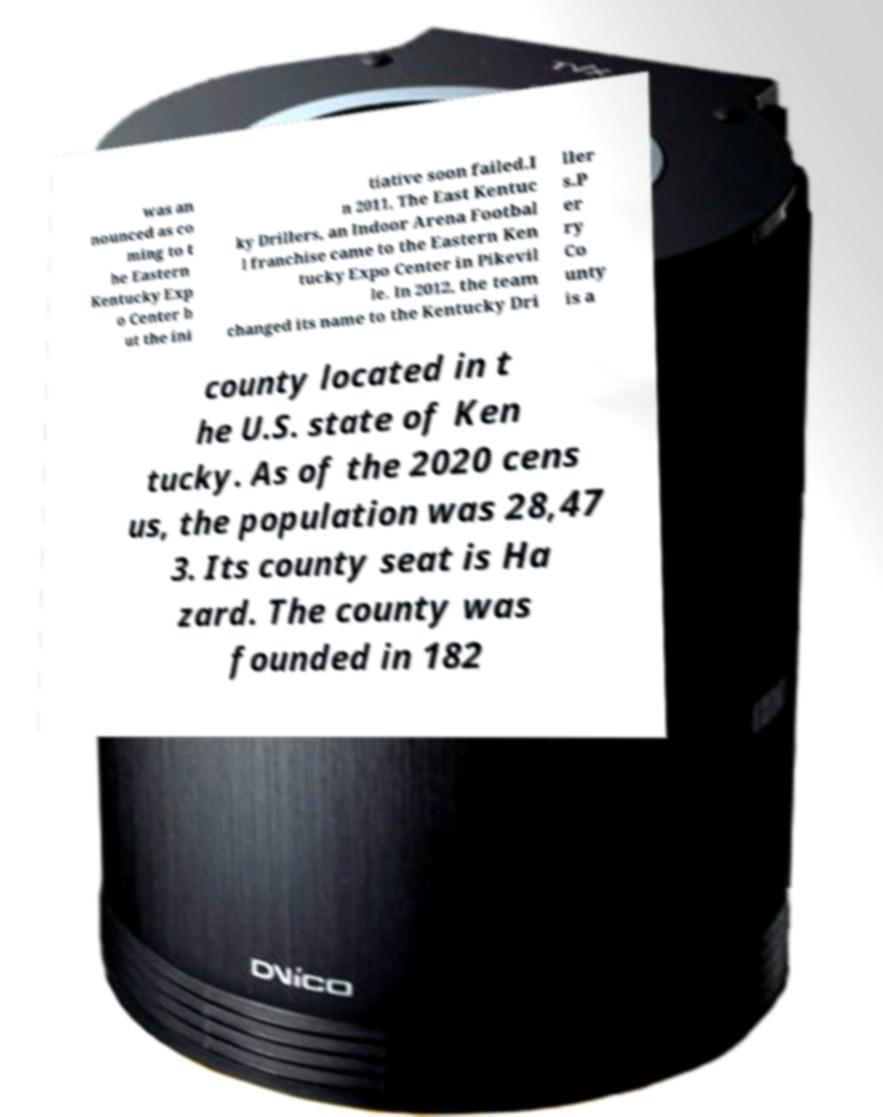Please read and relay the text visible in this image. What does it say? was an nounced as co ming to t he Eastern Kentucky Exp o Center b ut the ini tiative soon failed.I n 2011, The East Kentuc ky Drillers, an Indoor Arena Footbal l franchise came to the Eastern Ken tucky Expo Center in Pikevil le. In 2012, the team changed its name to the Kentucky Dri ller s.P er ry Co unty is a county located in t he U.S. state of Ken tucky. As of the 2020 cens us, the population was 28,47 3. Its county seat is Ha zard. The county was founded in 182 